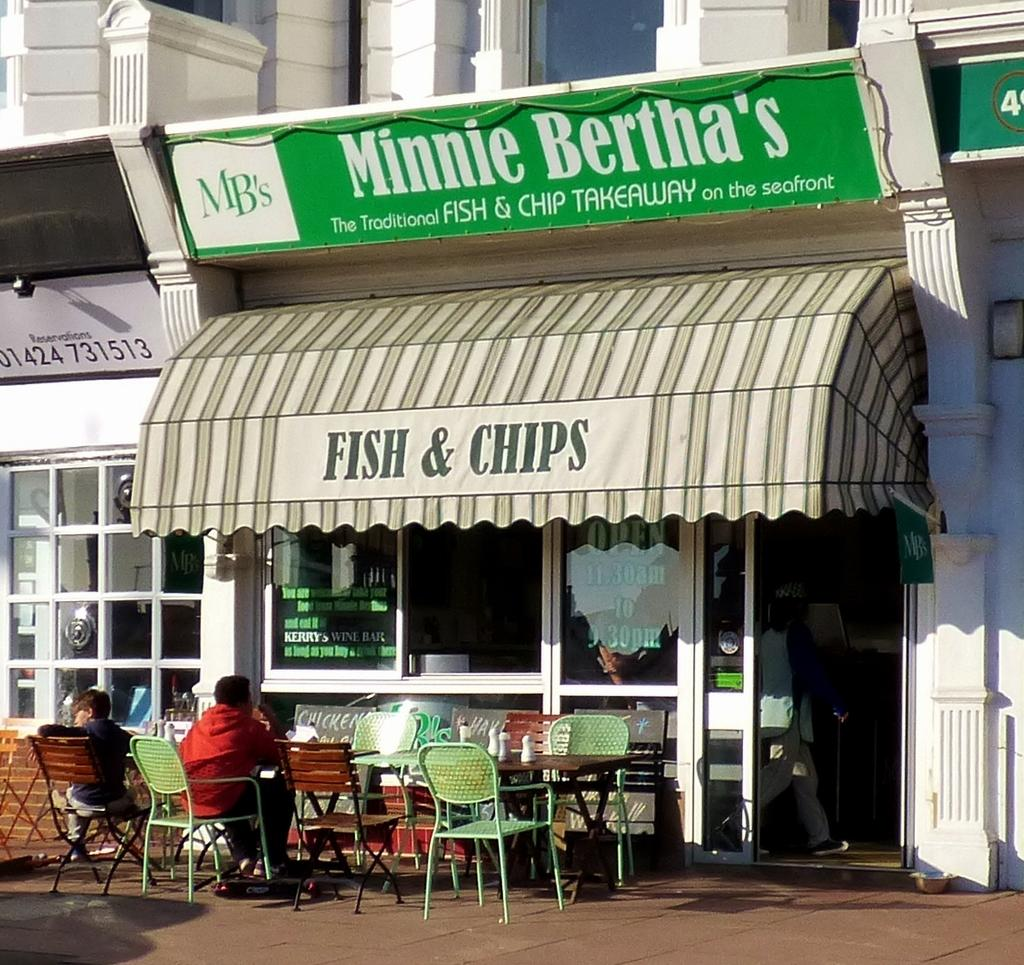What type of furniture is located in front of the store? There are tables and chairs in front of the store. What are people doing while sitting on the chairs? People are sitting on the chairs. What can be seen on the tables? There are bottles on the tables. What is happening inside the store? A person is walking (evidenced by leg movement). What type of peace symbol can be seen on the sheet in the image? There is no peace symbol or sheet present in the image. How many toads are visible on the tables in the image? There are no toads present in the image; only tables, chairs, and bottles are visible. 